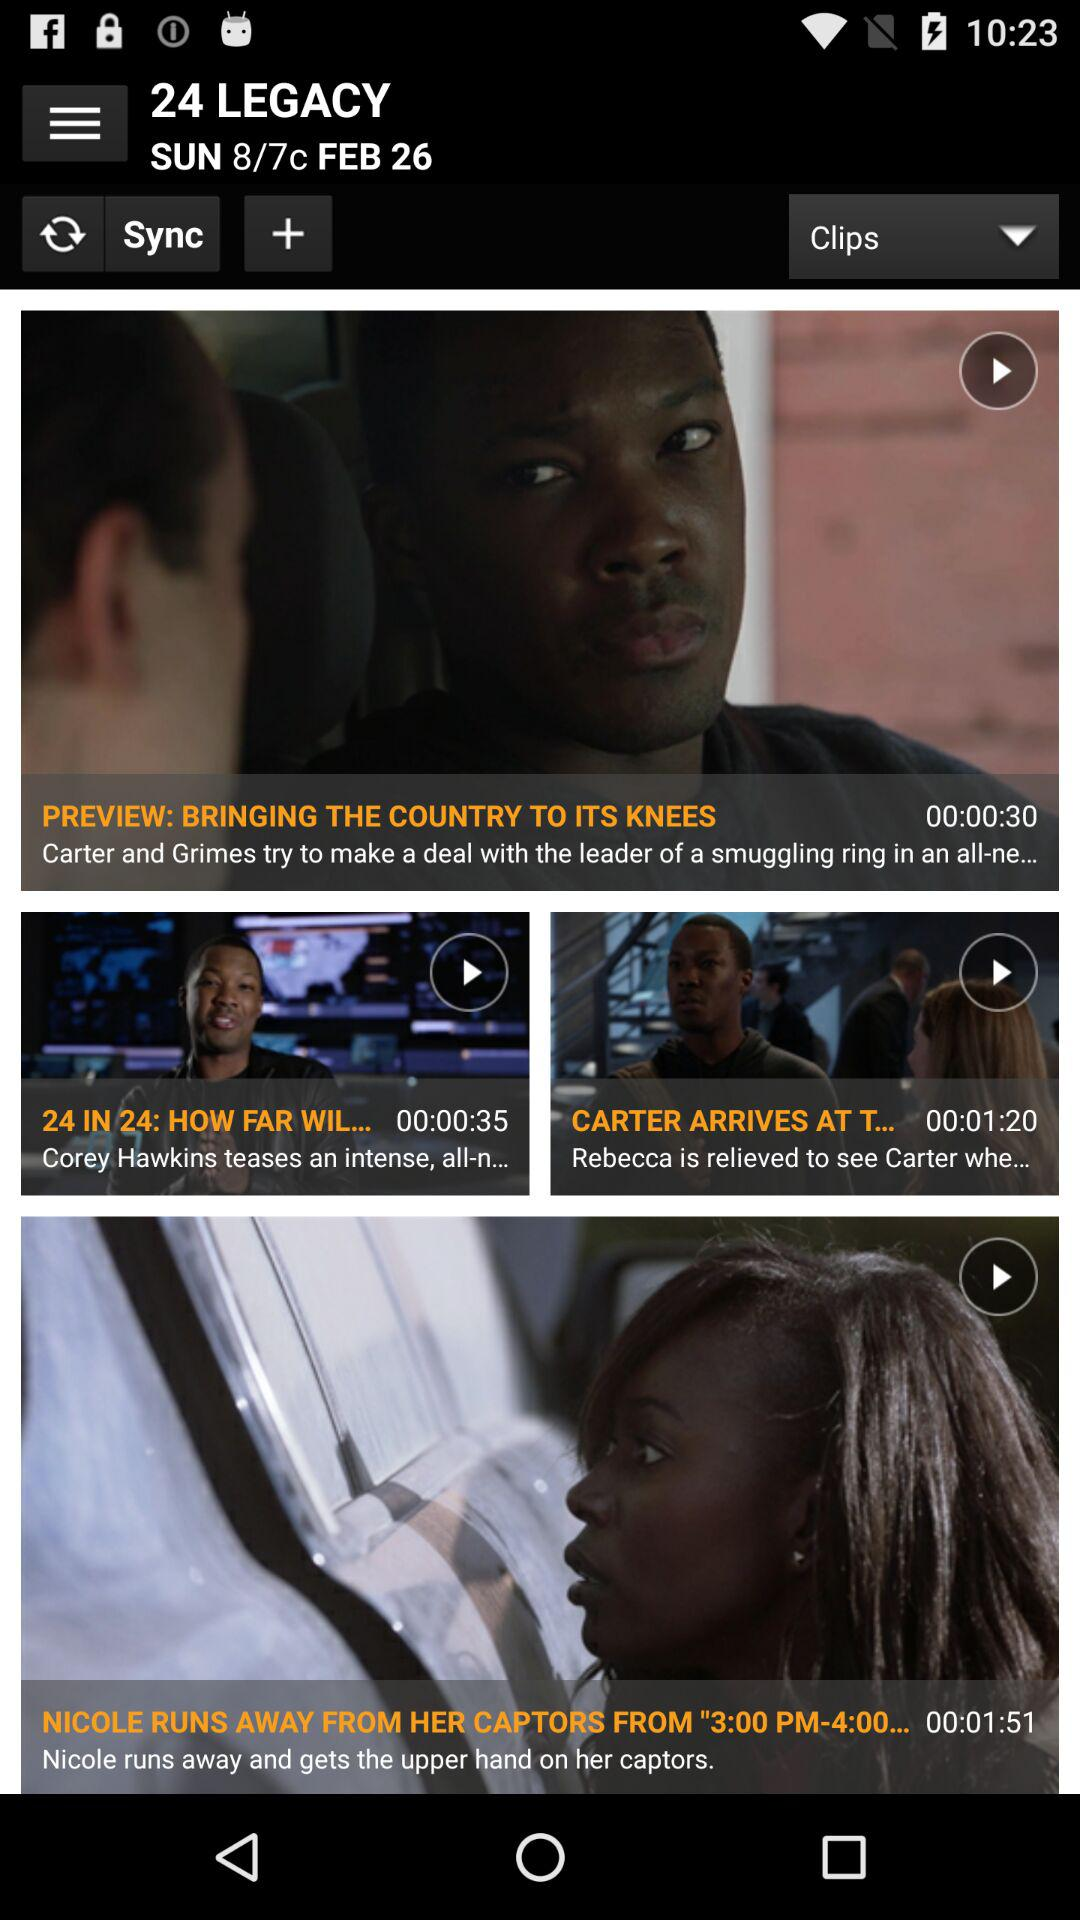What is the title of the series? The title of the series is "24 LEGACY". 